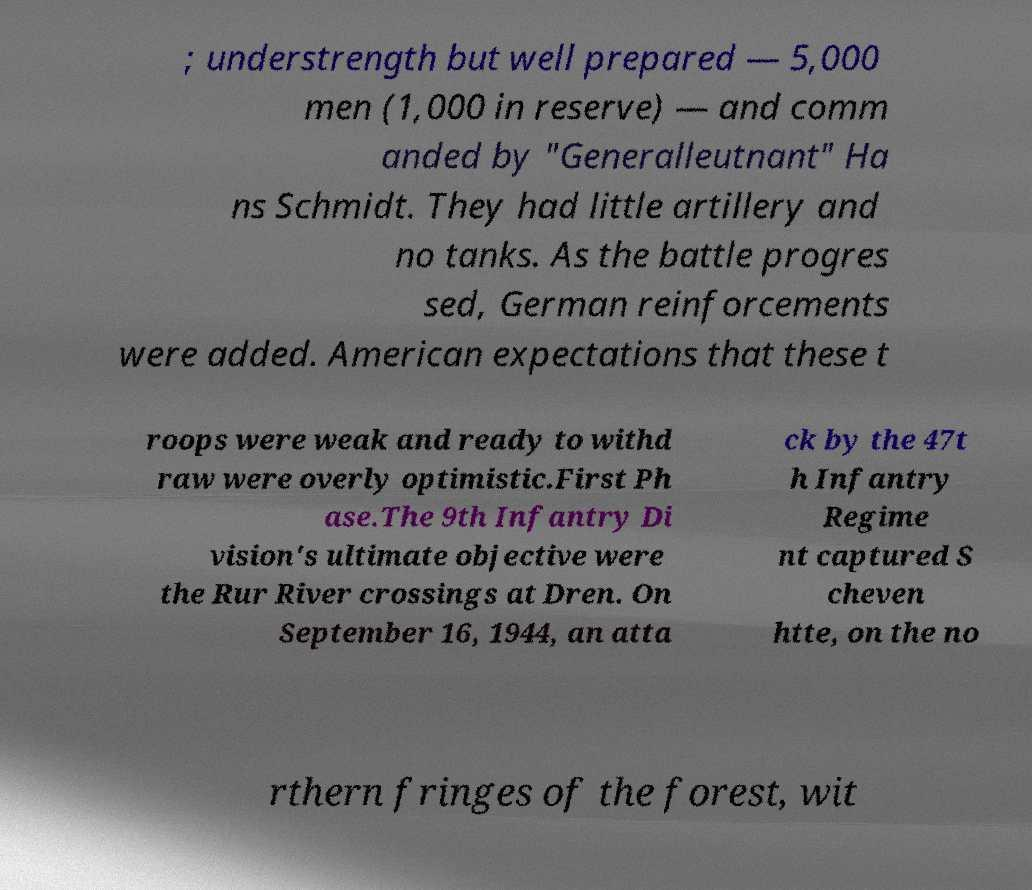Could you assist in decoding the text presented in this image and type it out clearly? ; understrength but well prepared — 5,000 men (1,000 in reserve) — and comm anded by "Generalleutnant" Ha ns Schmidt. They had little artillery and no tanks. As the battle progres sed, German reinforcements were added. American expectations that these t roops were weak and ready to withd raw were overly optimistic.First Ph ase.The 9th Infantry Di vision's ultimate objective were the Rur River crossings at Dren. On September 16, 1944, an atta ck by the 47t h Infantry Regime nt captured S cheven htte, on the no rthern fringes of the forest, wit 